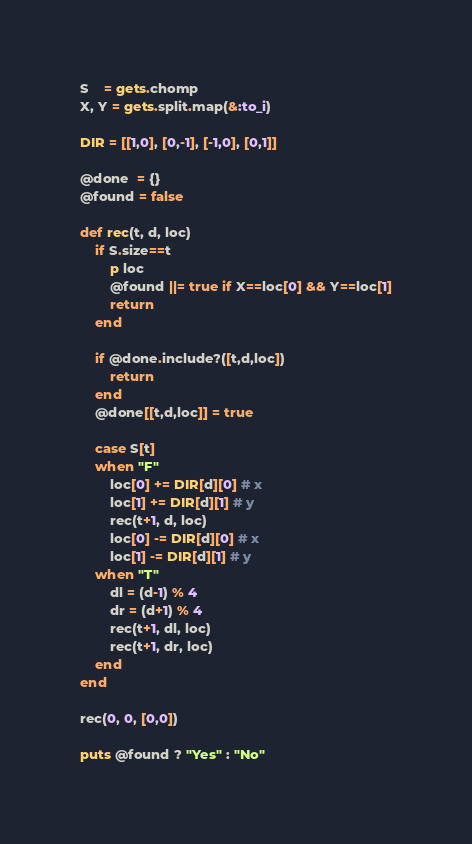Convert code to text. <code><loc_0><loc_0><loc_500><loc_500><_Ruby_>S    = gets.chomp
X, Y = gets.split.map(&:to_i)

DIR = [[1,0], [0,-1], [-1,0], [0,1]]

@done  = {}
@found = false

def rec(t, d, loc)
    if S.size==t
        p loc
        @found ||= true if X==loc[0] && Y==loc[1]
        return
    end
    
    if @done.include?([t,d,loc])
        return
    end
    @done[[t,d,loc]] = true
    
    case S[t]
    when "F"
        loc[0] += DIR[d][0] # x
        loc[1] += DIR[d][1] # y
        rec(t+1, d, loc)
        loc[0] -= DIR[d][0] # x
        loc[1] -= DIR[d][1] # y
    when "T"
        dl = (d-1) % 4
        dr = (d+1) % 4
        rec(t+1, dl, loc)
        rec(t+1, dr, loc)
    end
end

rec(0, 0, [0,0])

puts @found ? "Yes" : "No"</code> 